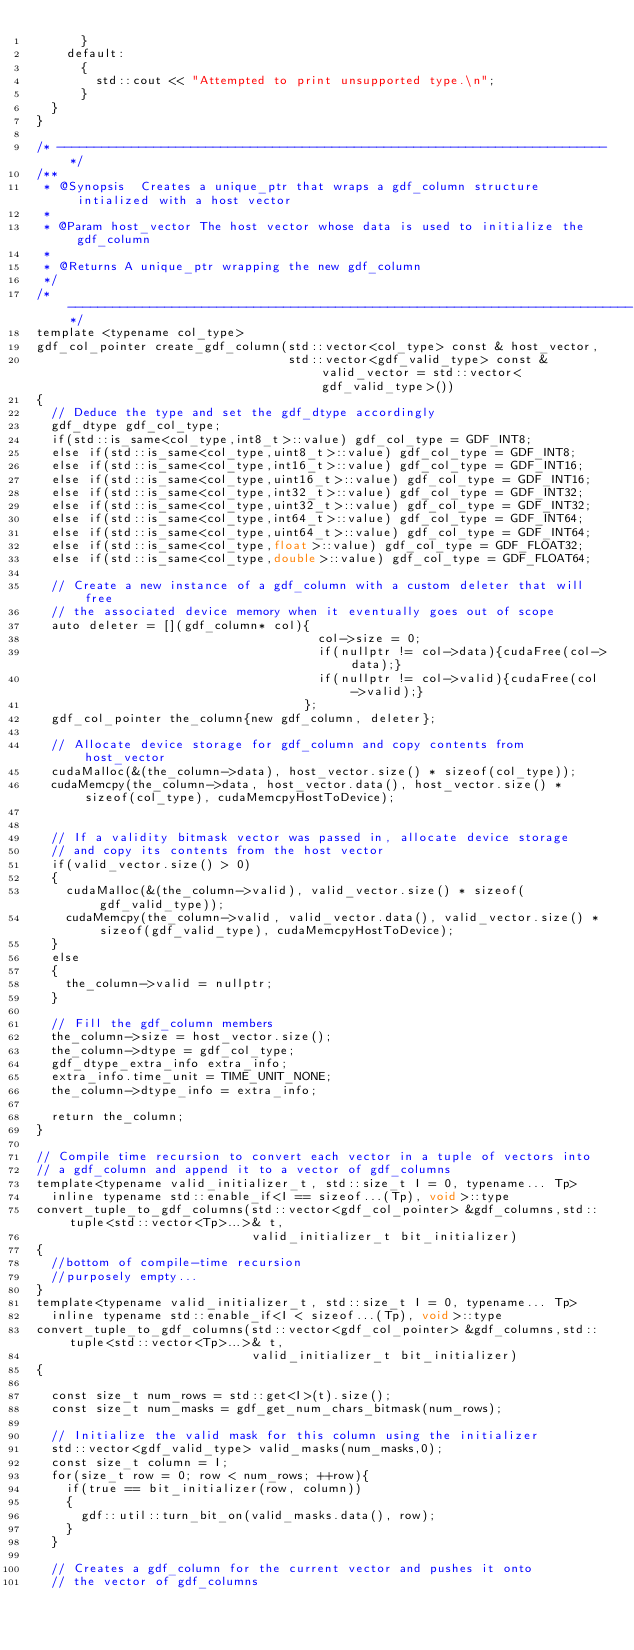<code> <loc_0><loc_0><loc_500><loc_500><_Cuda_>      }
    default:
      {
        std::cout << "Attempted to print unsupported type.\n";
      }
  }
}

/* --------------------------------------------------------------------------*/
/**
 * @Synopsis  Creates a unique_ptr that wraps a gdf_column structure intialized with a host vector
 *
 * @Param host_vector The host vector whose data is used to initialize the gdf_column
 *
 * @Returns A unique_ptr wrapping the new gdf_column
 */
/* ----------------------------------------------------------------------------*/
template <typename col_type>
gdf_col_pointer create_gdf_column(std::vector<col_type> const & host_vector,
                                  std::vector<gdf_valid_type> const & valid_vector = std::vector<gdf_valid_type>())
{
  // Deduce the type and set the gdf_dtype accordingly
  gdf_dtype gdf_col_type;
  if(std::is_same<col_type,int8_t>::value) gdf_col_type = GDF_INT8;
  else if(std::is_same<col_type,uint8_t>::value) gdf_col_type = GDF_INT8;
  else if(std::is_same<col_type,int16_t>::value) gdf_col_type = GDF_INT16;
  else if(std::is_same<col_type,uint16_t>::value) gdf_col_type = GDF_INT16;
  else if(std::is_same<col_type,int32_t>::value) gdf_col_type = GDF_INT32;
  else if(std::is_same<col_type,uint32_t>::value) gdf_col_type = GDF_INT32;
  else if(std::is_same<col_type,int64_t>::value) gdf_col_type = GDF_INT64;
  else if(std::is_same<col_type,uint64_t>::value) gdf_col_type = GDF_INT64;
  else if(std::is_same<col_type,float>::value) gdf_col_type = GDF_FLOAT32;
  else if(std::is_same<col_type,double>::value) gdf_col_type = GDF_FLOAT64;

  // Create a new instance of a gdf_column with a custom deleter that will free
  // the associated device memory when it eventually goes out of scope
  auto deleter = [](gdf_column* col){
                                      col->size = 0; 
                                      if(nullptr != col->data){cudaFree(col->data);} 
                                      if(nullptr != col->valid){cudaFree(col->valid);}
                                    };
  gdf_col_pointer the_column{new gdf_column, deleter};

  // Allocate device storage for gdf_column and copy contents from host_vector
  cudaMalloc(&(the_column->data), host_vector.size() * sizeof(col_type));
  cudaMemcpy(the_column->data, host_vector.data(), host_vector.size() * sizeof(col_type), cudaMemcpyHostToDevice);


  // If a validity bitmask vector was passed in, allocate device storage 
  // and copy its contents from the host vector
  if(valid_vector.size() > 0)
  {
    cudaMalloc(&(the_column->valid), valid_vector.size() * sizeof(gdf_valid_type));
    cudaMemcpy(the_column->valid, valid_vector.data(), valid_vector.size() * sizeof(gdf_valid_type), cudaMemcpyHostToDevice);
  }
  else
  {
    the_column->valid = nullptr;
  }

  // Fill the gdf_column members
  the_column->size = host_vector.size();
  the_column->dtype = gdf_col_type;
  gdf_dtype_extra_info extra_info;
  extra_info.time_unit = TIME_UNIT_NONE;
  the_column->dtype_info = extra_info;

  return the_column;
}

// Compile time recursion to convert each vector in a tuple of vectors into
// a gdf_column and append it to a vector of gdf_columns
template<typename valid_initializer_t, std::size_t I = 0, typename... Tp>
  inline typename std::enable_if<I == sizeof...(Tp), void>::type
convert_tuple_to_gdf_columns(std::vector<gdf_col_pointer> &gdf_columns,std::tuple<std::vector<Tp>...>& t, 
                             valid_initializer_t bit_initializer)
{
  //bottom of compile-time recursion
  //purposely empty...
}
template<typename valid_initializer_t, std::size_t I = 0, typename... Tp>
  inline typename std::enable_if<I < sizeof...(Tp), void>::type
convert_tuple_to_gdf_columns(std::vector<gdf_col_pointer> &gdf_columns,std::tuple<std::vector<Tp>...>& t,
                             valid_initializer_t bit_initializer)
{

  const size_t num_rows = std::get<I>(t).size();
  const size_t num_masks = gdf_get_num_chars_bitmask(num_rows);

  // Initialize the valid mask for this column using the initializer
  std::vector<gdf_valid_type> valid_masks(num_masks,0);
  const size_t column = I;
  for(size_t row = 0; row < num_rows; ++row){
    if(true == bit_initializer(row, column))
    {
      gdf::util::turn_bit_on(valid_masks.data(), row);
    }
  }

  // Creates a gdf_column for the current vector and pushes it onto
  // the vector of gdf_columns</code> 